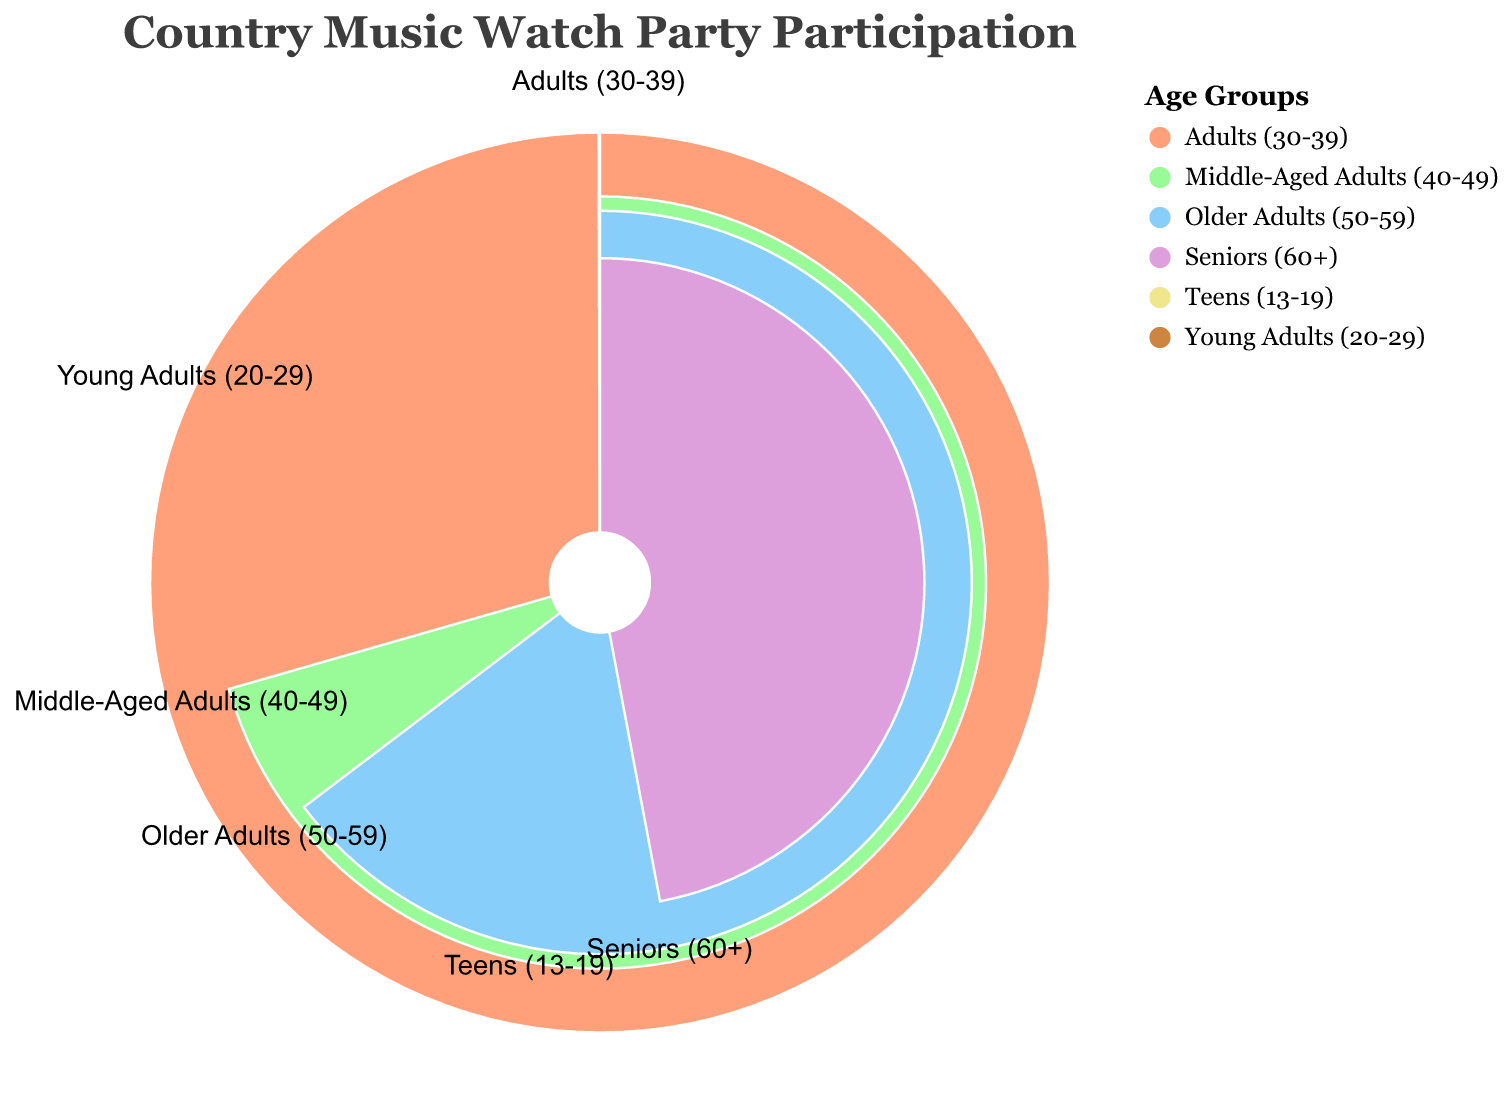What's the demographic group with the highest average participation time? The chart shows the radial lengths representing average participation times. The longest length corresponds to the "Adults (30-39)" group.
Answer: Adults (30-39) What's the total average participation time for Teens (13-19) and Seniors (60+)? You need to sum the average participation times for Teens and Seniors. 45 minutes (Teens) + 40 minutes (Seniors) = 85 minutes.
Answer: 85 minutes Which demographic group follows the Adults (30-39) in terms of average participation time? By observing the radial lengths or categories near "Adults (30-39)," the next longest length corresponds to the "Young Adults (20-29)" group.
Answer: Young Adults (20-29) How much more average participation time do Middle-Aged Adults (40-49) have compared to Older Adults (50-59)? Subtract the average participation time of Older Adults from that of Middle-Aged Adults. 60 minutes (Middle-Aged Adults) - 55 minutes (Older Adults) = 5 minutes.
Answer: 5 minutes What is the average participation time of all demographic groups combined? Sum the given participation times and divide by the number of groups: (45 + 70 + 85 + 60 + 55 + 40) / 6 = 60.83 minutes.
Answer: 60.83 minutes Between which two demographic groups is the smallest difference in average participation time? Compare differences between all pairs: The smallest difference is between Older Adults (50-59) and Middle-Aged Adults (40-49), which is 60 - 55 = 5 minutes.
Answer: Older Adults (50-59) and Middle-Aged Adults (40-49) What percentage of total average participation time is contributed by Adults (30-39)? First, find the total time: 45 + 70 + 85 + 60 + 55 + 40 = 355 minutes. Then, (85 / 355) * 100 = 23.94%.
Answer: 23.94% Which demographic groups have an average participation time greater than Seniors (60+)? Compare the participation times: Teens (45), Young Adults (70), Adults (85), Middle-Aged Adults (60), and Older Adults (55) are all greater than Seniors (40).
Answer: Teens (13-19), Young Adults (20-29), Adults (30-39), Middle-Aged Adults (40-49), Older Adults (50-59) Which group has the lowest average participation time? By observing the shortest radial lengths, the "Seniors (60+)" group has the smallest value.
Answer: Seniors (60+) How does the participation time of Young Adults (20-29) compare to that of Older Adults (50-59)? The participation time of Young Adults (70 minutes) is greater than that of Older Adults (55 minutes).
Answer: Greater than 